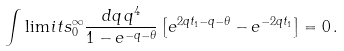Convert formula to latex. <formula><loc_0><loc_0><loc_500><loc_500>\int \lim i t s _ { 0 } ^ { \infty } \frac { d q \, q ^ { 4 } } { 1 - e ^ { - q - \theta } } \left [ e ^ { 2 q t _ { 1 } - q - \theta } - e ^ { - 2 q t _ { 1 } } \right ] = 0 \, .</formula> 